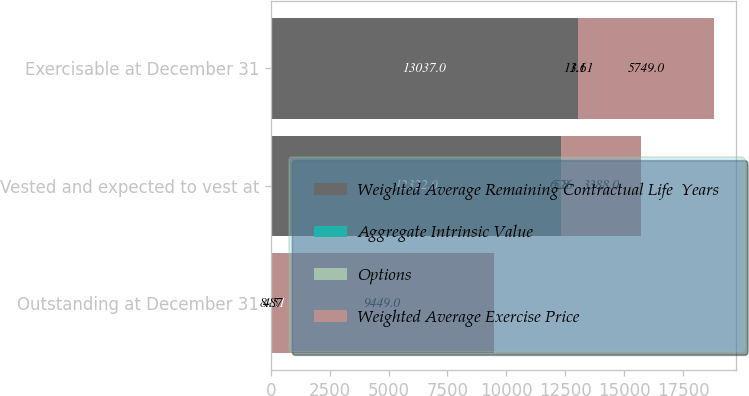Convert chart to OTSL. <chart><loc_0><loc_0><loc_500><loc_500><stacked_bar_chart><ecel><fcel>Outstanding at December 31<fcel>Vested and expected to vest at<fcel>Exercisable at December 31<nl><fcel>Weighted Average Remaining Contractual Life  Years<fcel>11.61<fcel>12322<fcel>13037<nl><fcel>Aggregate Intrinsic Value<fcel>8.87<fcel>6.26<fcel>11.61<nl><fcel>Options<fcel>4.5<fcel>5.8<fcel>3.1<nl><fcel>Weighted Average Exercise Price<fcel>9449<fcel>3388<fcel>5749<nl></chart> 